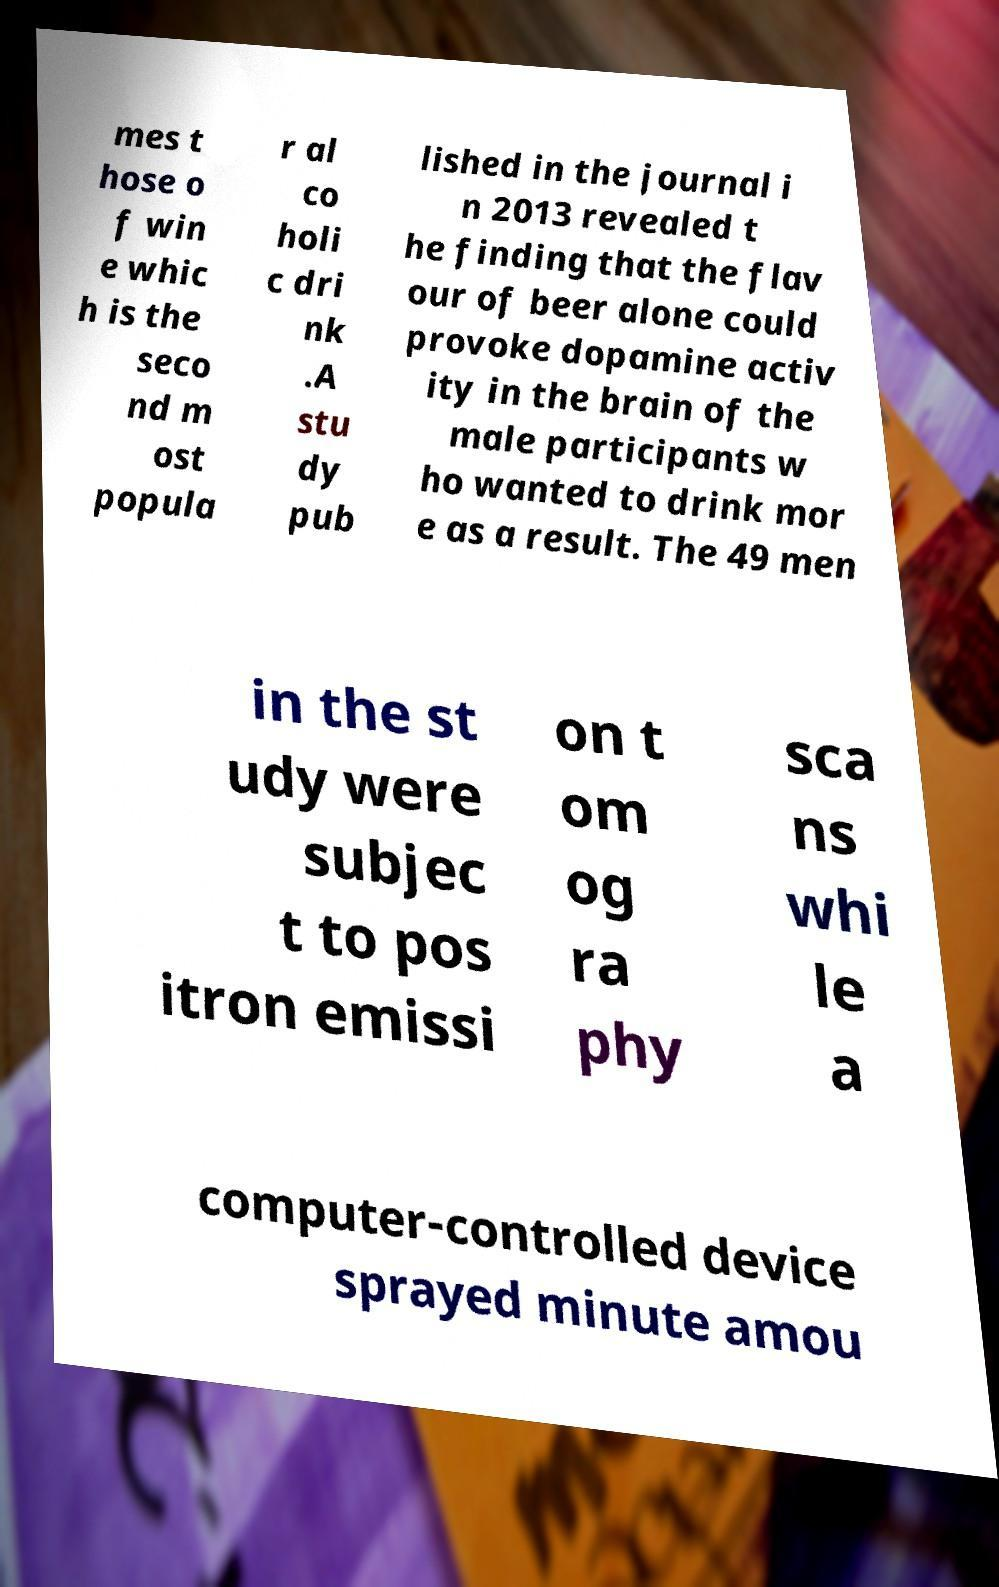There's text embedded in this image that I need extracted. Can you transcribe it verbatim? mes t hose o f win e whic h is the seco nd m ost popula r al co holi c dri nk .A stu dy pub lished in the journal i n 2013 revealed t he finding that the flav our of beer alone could provoke dopamine activ ity in the brain of the male participants w ho wanted to drink mor e as a result. The 49 men in the st udy were subjec t to pos itron emissi on t om og ra phy sca ns whi le a computer-controlled device sprayed minute amou 